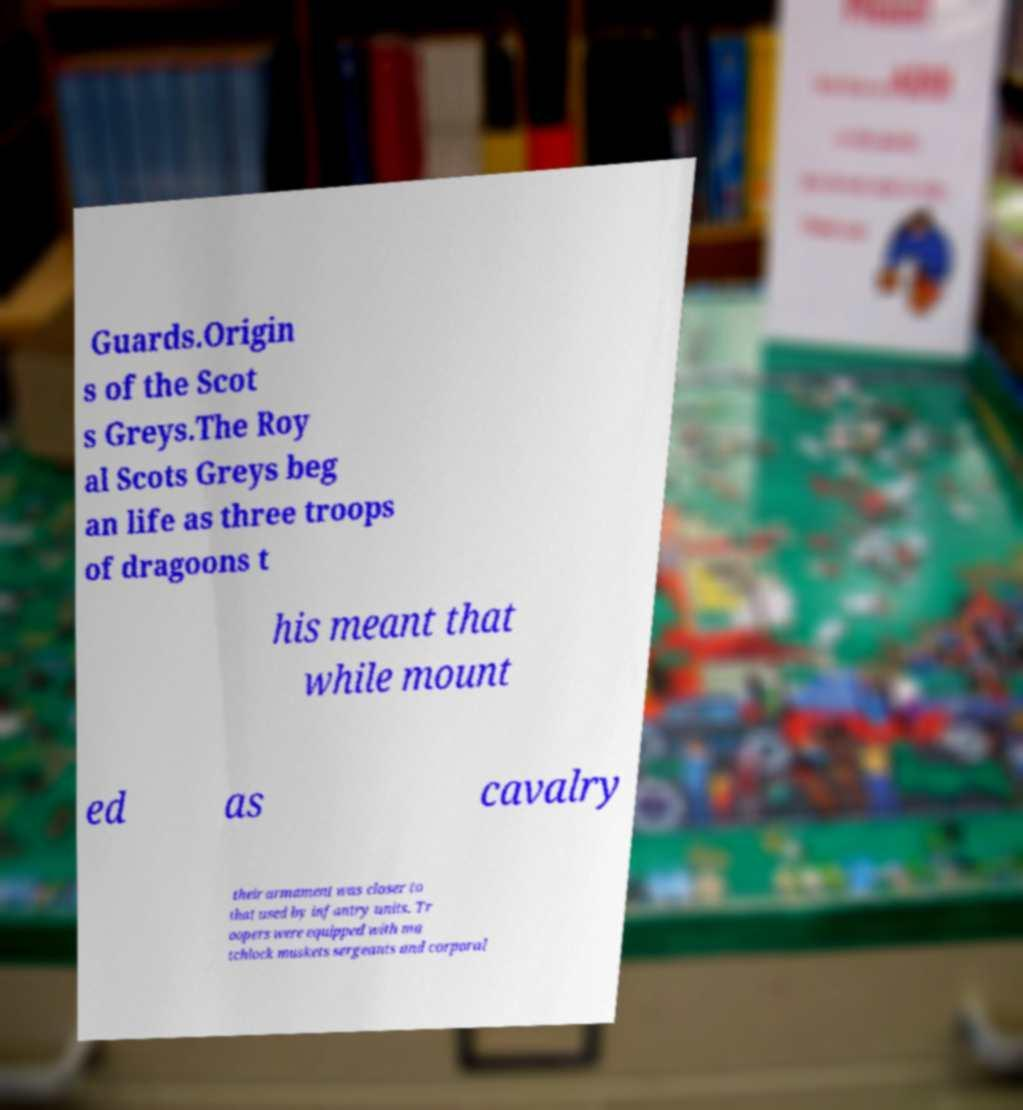I need the written content from this picture converted into text. Can you do that? Guards.Origin s of the Scot s Greys.The Roy al Scots Greys beg an life as three troops of dragoons t his meant that while mount ed as cavalry their armament was closer to that used by infantry units. Tr oopers were equipped with ma tchlock muskets sergeants and corporal 